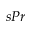<formula> <loc_0><loc_0><loc_500><loc_500>s P r</formula> 